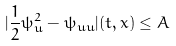<formula> <loc_0><loc_0><loc_500><loc_500>| \frac { 1 } { 2 } \psi _ { u } ^ { 2 } - \psi _ { u u } | ( t , x ) \leq A</formula> 